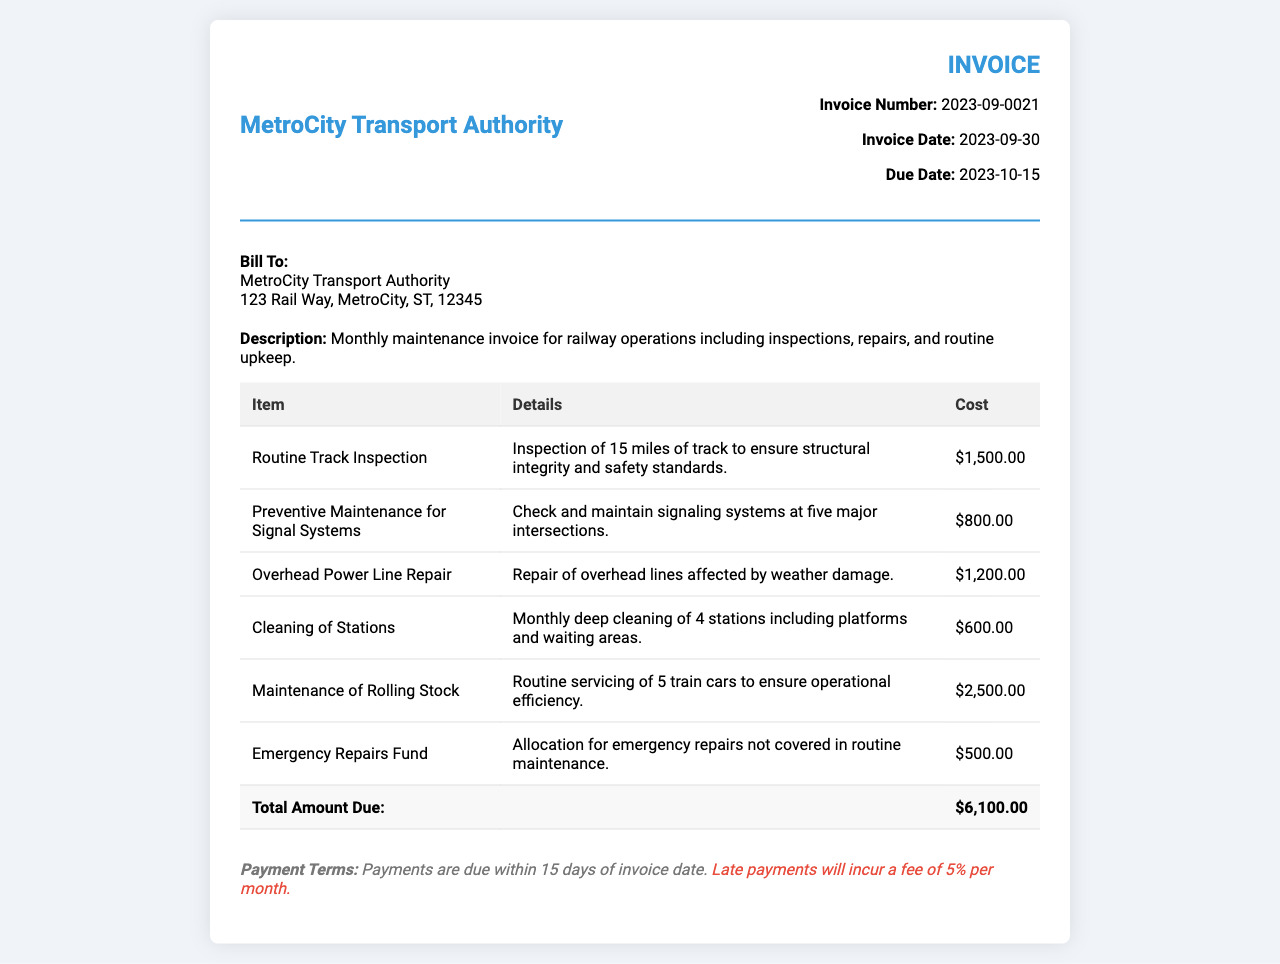What is the invoice number? The invoice number is clearly stated in the document as a specific identifier for this transaction.
Answer: 2023-09-0021 What is the total amount due? The total amount due at the bottom of the invoice summarizes all costs listed in the table.
Answer: $6,100.00 How many miles of track were inspected? The document specifies that 15 miles of track were inspected as part of the routine inspection.
Answer: 15 miles What is the due date for the payment? The due date is explicitly mentioned in the invoice details for timely payment.
Answer: 2023-10-15 What is included in the preventive maintenance? The invoice provides specific details about maintenance tasks, indicating what is covered under this service.
Answer: Check and maintain signaling systems at five major intersections How much was allocated for emergency repairs? The document details the allocation for emergency repairs in a specific line item of the invoice.
Answer: $500.00 What is the payment term for late payments? The invoice outlines the consequences of late payments to provide clear terms for financial responsibility.
Answer: 5% per month How many train cars were serviced? The document indicates the quantity of train cars that underwent maintenance as part of the routine servicing.
Answer: 5 train cars What service was billed for cleaning? The document specifies a cleaning service, detailing what locations were included in that charge.
Answer: Monthly deep cleaning of 4 stations 